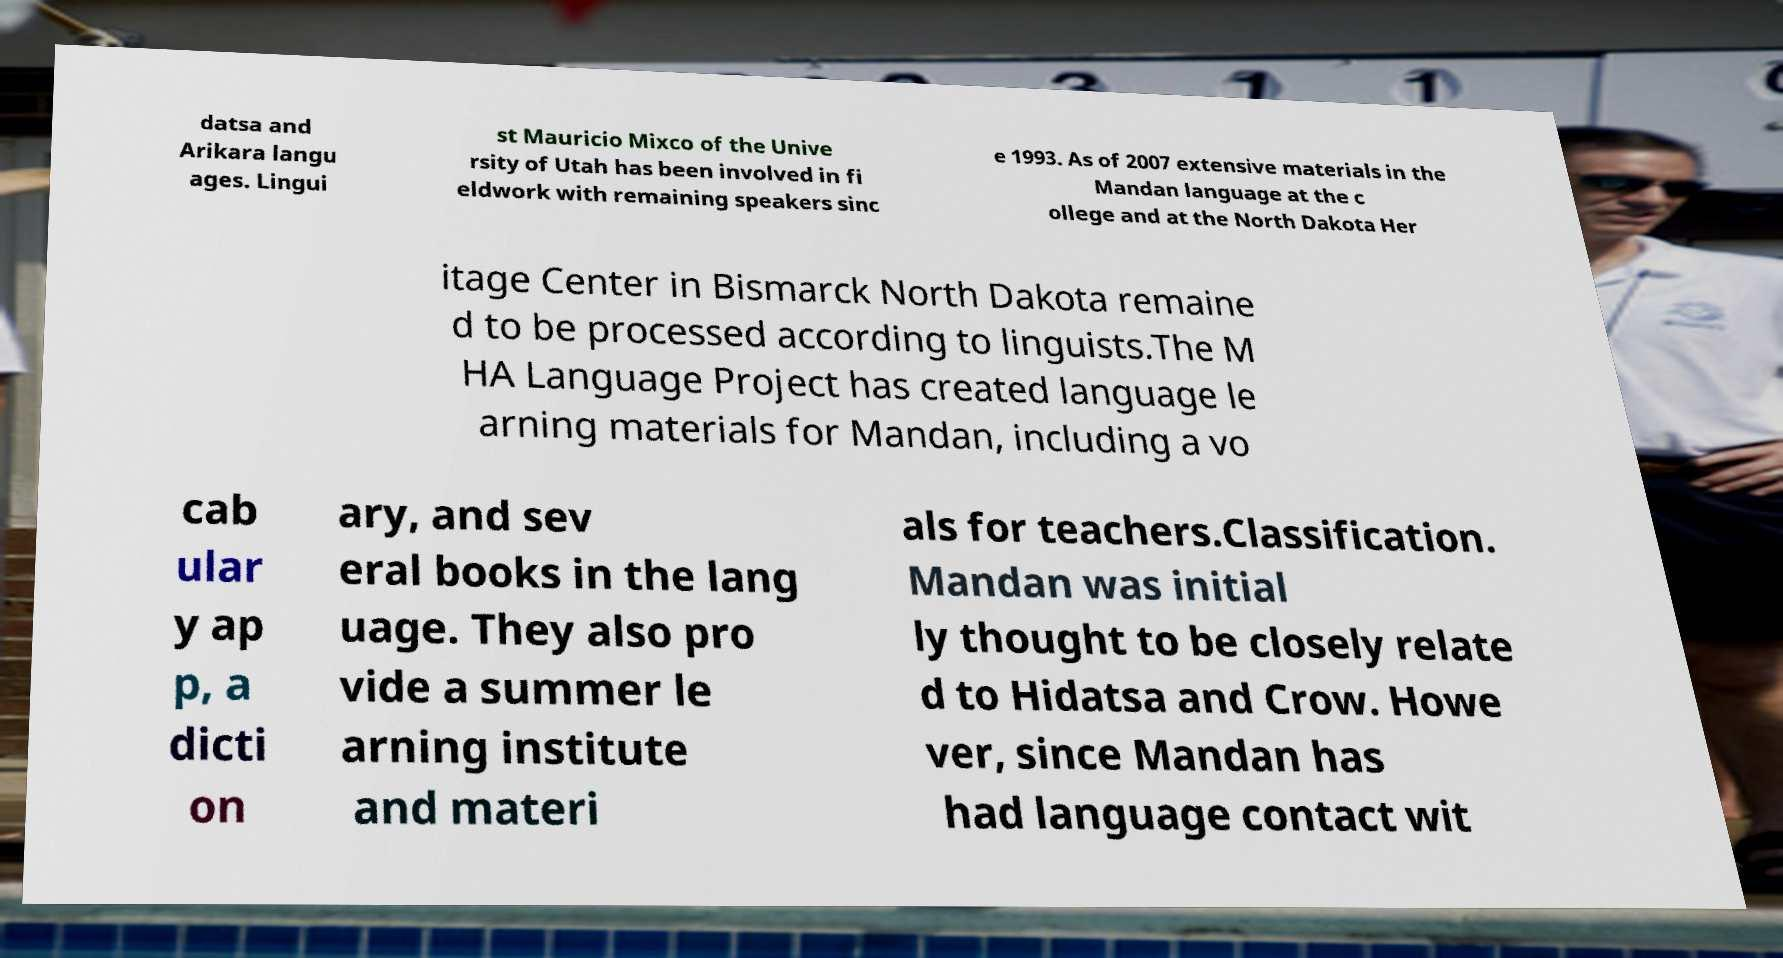Please identify and transcribe the text found in this image. datsa and Arikara langu ages. Lingui st Mauricio Mixco of the Unive rsity of Utah has been involved in fi eldwork with remaining speakers sinc e 1993. As of 2007 extensive materials in the Mandan language at the c ollege and at the North Dakota Her itage Center in Bismarck North Dakota remaine d to be processed according to linguists.The M HA Language Project has created language le arning materials for Mandan, including a vo cab ular y ap p, a dicti on ary, and sev eral books in the lang uage. They also pro vide a summer le arning institute and materi als for teachers.Classification. Mandan was initial ly thought to be closely relate d to Hidatsa and Crow. Howe ver, since Mandan has had language contact wit 